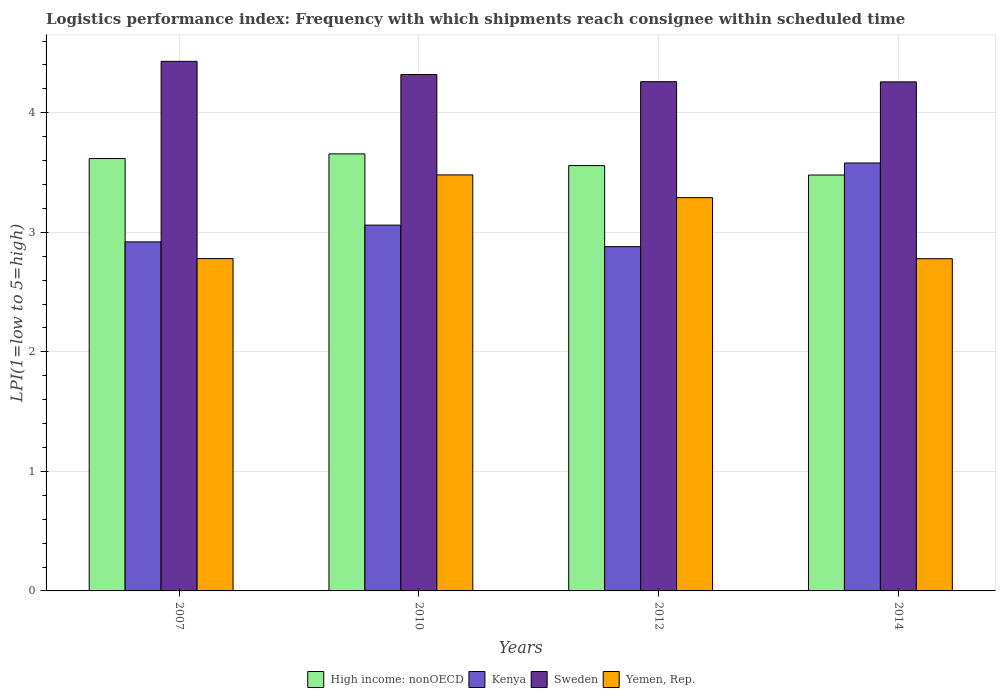How many different coloured bars are there?
Your answer should be very brief. 4. How many groups of bars are there?
Your response must be concise. 4. Are the number of bars on each tick of the X-axis equal?
Your answer should be compact. Yes. What is the label of the 1st group of bars from the left?
Ensure brevity in your answer.  2007. In how many cases, is the number of bars for a given year not equal to the number of legend labels?
Ensure brevity in your answer.  0. What is the logistics performance index in High income: nonOECD in 2014?
Give a very brief answer. 3.48. Across all years, what is the maximum logistics performance index in High income: nonOECD?
Your response must be concise. 3.66. Across all years, what is the minimum logistics performance index in High income: nonOECD?
Keep it short and to the point. 3.48. What is the total logistics performance index in Kenya in the graph?
Your answer should be compact. 12.44. What is the difference between the logistics performance index in Yemen, Rep. in 2007 and that in 2010?
Offer a terse response. -0.7. What is the difference between the logistics performance index in High income: nonOECD in 2007 and the logistics performance index in Yemen, Rep. in 2012?
Your answer should be compact. 0.33. What is the average logistics performance index in High income: nonOECD per year?
Your answer should be compact. 3.58. In the year 2012, what is the difference between the logistics performance index in High income: nonOECD and logistics performance index in Yemen, Rep.?
Keep it short and to the point. 0.27. What is the ratio of the logistics performance index in Yemen, Rep. in 2007 to that in 2012?
Your response must be concise. 0.84. Is the difference between the logistics performance index in High income: nonOECD in 2007 and 2010 greater than the difference between the logistics performance index in Yemen, Rep. in 2007 and 2010?
Your answer should be compact. Yes. What is the difference between the highest and the second highest logistics performance index in Kenya?
Offer a very short reply. 0.52. What is the difference between the highest and the lowest logistics performance index in Yemen, Rep.?
Your response must be concise. 0.7. Is the sum of the logistics performance index in Kenya in 2010 and 2014 greater than the maximum logistics performance index in High income: nonOECD across all years?
Your response must be concise. Yes. Is it the case that in every year, the sum of the logistics performance index in Sweden and logistics performance index in Kenya is greater than the sum of logistics performance index in High income: nonOECD and logistics performance index in Yemen, Rep.?
Give a very brief answer. Yes. What does the 4th bar from the left in 2014 represents?
Your answer should be compact. Yemen, Rep. What does the 4th bar from the right in 2012 represents?
Keep it short and to the point. High income: nonOECD. Are the values on the major ticks of Y-axis written in scientific E-notation?
Keep it short and to the point. No. Does the graph contain grids?
Make the answer very short. Yes. How many legend labels are there?
Offer a terse response. 4. How are the legend labels stacked?
Your response must be concise. Horizontal. What is the title of the graph?
Your answer should be very brief. Logistics performance index: Frequency with which shipments reach consignee within scheduled time. What is the label or title of the Y-axis?
Your response must be concise. LPI(1=low to 5=high). What is the LPI(1=low to 5=high) of High income: nonOECD in 2007?
Ensure brevity in your answer.  3.62. What is the LPI(1=low to 5=high) of Kenya in 2007?
Make the answer very short. 2.92. What is the LPI(1=low to 5=high) of Sweden in 2007?
Provide a short and direct response. 4.43. What is the LPI(1=low to 5=high) of Yemen, Rep. in 2007?
Your response must be concise. 2.78. What is the LPI(1=low to 5=high) of High income: nonOECD in 2010?
Offer a terse response. 3.66. What is the LPI(1=low to 5=high) in Kenya in 2010?
Offer a terse response. 3.06. What is the LPI(1=low to 5=high) of Sweden in 2010?
Your response must be concise. 4.32. What is the LPI(1=low to 5=high) of Yemen, Rep. in 2010?
Provide a succinct answer. 3.48. What is the LPI(1=low to 5=high) in High income: nonOECD in 2012?
Your answer should be compact. 3.56. What is the LPI(1=low to 5=high) of Kenya in 2012?
Your answer should be very brief. 2.88. What is the LPI(1=low to 5=high) of Sweden in 2012?
Offer a very short reply. 4.26. What is the LPI(1=low to 5=high) of Yemen, Rep. in 2012?
Your answer should be compact. 3.29. What is the LPI(1=low to 5=high) in High income: nonOECD in 2014?
Offer a very short reply. 3.48. What is the LPI(1=low to 5=high) in Kenya in 2014?
Your response must be concise. 3.58. What is the LPI(1=low to 5=high) in Sweden in 2014?
Your answer should be compact. 4.26. What is the LPI(1=low to 5=high) of Yemen, Rep. in 2014?
Ensure brevity in your answer.  2.78. Across all years, what is the maximum LPI(1=low to 5=high) in High income: nonOECD?
Make the answer very short. 3.66. Across all years, what is the maximum LPI(1=low to 5=high) of Kenya?
Provide a succinct answer. 3.58. Across all years, what is the maximum LPI(1=low to 5=high) of Sweden?
Make the answer very short. 4.43. Across all years, what is the maximum LPI(1=low to 5=high) in Yemen, Rep.?
Your answer should be compact. 3.48. Across all years, what is the minimum LPI(1=low to 5=high) in High income: nonOECD?
Offer a terse response. 3.48. Across all years, what is the minimum LPI(1=low to 5=high) of Kenya?
Ensure brevity in your answer.  2.88. Across all years, what is the minimum LPI(1=low to 5=high) of Sweden?
Give a very brief answer. 4.26. Across all years, what is the minimum LPI(1=low to 5=high) in Yemen, Rep.?
Offer a terse response. 2.78. What is the total LPI(1=low to 5=high) of High income: nonOECD in the graph?
Keep it short and to the point. 14.31. What is the total LPI(1=low to 5=high) in Kenya in the graph?
Your answer should be compact. 12.44. What is the total LPI(1=low to 5=high) of Sweden in the graph?
Your answer should be compact. 17.27. What is the total LPI(1=low to 5=high) of Yemen, Rep. in the graph?
Your answer should be very brief. 12.33. What is the difference between the LPI(1=low to 5=high) in High income: nonOECD in 2007 and that in 2010?
Provide a succinct answer. -0.04. What is the difference between the LPI(1=low to 5=high) in Kenya in 2007 and that in 2010?
Give a very brief answer. -0.14. What is the difference between the LPI(1=low to 5=high) in Sweden in 2007 and that in 2010?
Give a very brief answer. 0.11. What is the difference between the LPI(1=low to 5=high) in Yemen, Rep. in 2007 and that in 2010?
Ensure brevity in your answer.  -0.7. What is the difference between the LPI(1=low to 5=high) of High income: nonOECD in 2007 and that in 2012?
Provide a succinct answer. 0.06. What is the difference between the LPI(1=low to 5=high) in Sweden in 2007 and that in 2012?
Make the answer very short. 0.17. What is the difference between the LPI(1=low to 5=high) in Yemen, Rep. in 2007 and that in 2012?
Provide a short and direct response. -0.51. What is the difference between the LPI(1=low to 5=high) in High income: nonOECD in 2007 and that in 2014?
Your answer should be very brief. 0.14. What is the difference between the LPI(1=low to 5=high) of Kenya in 2007 and that in 2014?
Give a very brief answer. -0.66. What is the difference between the LPI(1=low to 5=high) of Sweden in 2007 and that in 2014?
Make the answer very short. 0.17. What is the difference between the LPI(1=low to 5=high) of Yemen, Rep. in 2007 and that in 2014?
Ensure brevity in your answer.  0. What is the difference between the LPI(1=low to 5=high) in High income: nonOECD in 2010 and that in 2012?
Provide a short and direct response. 0.1. What is the difference between the LPI(1=low to 5=high) of Kenya in 2010 and that in 2012?
Ensure brevity in your answer.  0.18. What is the difference between the LPI(1=low to 5=high) in Sweden in 2010 and that in 2012?
Your answer should be very brief. 0.06. What is the difference between the LPI(1=low to 5=high) of Yemen, Rep. in 2010 and that in 2012?
Make the answer very short. 0.19. What is the difference between the LPI(1=low to 5=high) in High income: nonOECD in 2010 and that in 2014?
Make the answer very short. 0.18. What is the difference between the LPI(1=low to 5=high) in Kenya in 2010 and that in 2014?
Your answer should be compact. -0.52. What is the difference between the LPI(1=low to 5=high) in Sweden in 2010 and that in 2014?
Make the answer very short. 0.06. What is the difference between the LPI(1=low to 5=high) of Yemen, Rep. in 2010 and that in 2014?
Keep it short and to the point. 0.7. What is the difference between the LPI(1=low to 5=high) of High income: nonOECD in 2012 and that in 2014?
Keep it short and to the point. 0.08. What is the difference between the LPI(1=low to 5=high) of Kenya in 2012 and that in 2014?
Provide a succinct answer. -0.7. What is the difference between the LPI(1=low to 5=high) of Sweden in 2012 and that in 2014?
Provide a succinct answer. 0. What is the difference between the LPI(1=low to 5=high) of Yemen, Rep. in 2012 and that in 2014?
Give a very brief answer. 0.51. What is the difference between the LPI(1=low to 5=high) in High income: nonOECD in 2007 and the LPI(1=low to 5=high) in Kenya in 2010?
Provide a short and direct response. 0.56. What is the difference between the LPI(1=low to 5=high) of High income: nonOECD in 2007 and the LPI(1=low to 5=high) of Sweden in 2010?
Your answer should be compact. -0.7. What is the difference between the LPI(1=low to 5=high) of High income: nonOECD in 2007 and the LPI(1=low to 5=high) of Yemen, Rep. in 2010?
Provide a succinct answer. 0.14. What is the difference between the LPI(1=low to 5=high) in Kenya in 2007 and the LPI(1=low to 5=high) in Yemen, Rep. in 2010?
Make the answer very short. -0.56. What is the difference between the LPI(1=low to 5=high) in High income: nonOECD in 2007 and the LPI(1=low to 5=high) in Kenya in 2012?
Keep it short and to the point. 0.74. What is the difference between the LPI(1=low to 5=high) of High income: nonOECD in 2007 and the LPI(1=low to 5=high) of Sweden in 2012?
Your response must be concise. -0.64. What is the difference between the LPI(1=low to 5=high) in High income: nonOECD in 2007 and the LPI(1=low to 5=high) in Yemen, Rep. in 2012?
Keep it short and to the point. 0.33. What is the difference between the LPI(1=low to 5=high) in Kenya in 2007 and the LPI(1=low to 5=high) in Sweden in 2012?
Keep it short and to the point. -1.34. What is the difference between the LPI(1=low to 5=high) in Kenya in 2007 and the LPI(1=low to 5=high) in Yemen, Rep. in 2012?
Ensure brevity in your answer.  -0.37. What is the difference between the LPI(1=low to 5=high) in Sweden in 2007 and the LPI(1=low to 5=high) in Yemen, Rep. in 2012?
Give a very brief answer. 1.14. What is the difference between the LPI(1=low to 5=high) in High income: nonOECD in 2007 and the LPI(1=low to 5=high) in Kenya in 2014?
Give a very brief answer. 0.04. What is the difference between the LPI(1=low to 5=high) in High income: nonOECD in 2007 and the LPI(1=low to 5=high) in Sweden in 2014?
Provide a succinct answer. -0.64. What is the difference between the LPI(1=low to 5=high) in High income: nonOECD in 2007 and the LPI(1=low to 5=high) in Yemen, Rep. in 2014?
Offer a very short reply. 0.84. What is the difference between the LPI(1=low to 5=high) of Kenya in 2007 and the LPI(1=low to 5=high) of Sweden in 2014?
Your answer should be very brief. -1.34. What is the difference between the LPI(1=low to 5=high) in Kenya in 2007 and the LPI(1=low to 5=high) in Yemen, Rep. in 2014?
Ensure brevity in your answer.  0.14. What is the difference between the LPI(1=low to 5=high) in Sweden in 2007 and the LPI(1=low to 5=high) in Yemen, Rep. in 2014?
Your response must be concise. 1.65. What is the difference between the LPI(1=low to 5=high) of High income: nonOECD in 2010 and the LPI(1=low to 5=high) of Kenya in 2012?
Give a very brief answer. 0.78. What is the difference between the LPI(1=low to 5=high) in High income: nonOECD in 2010 and the LPI(1=low to 5=high) in Sweden in 2012?
Provide a short and direct response. -0.6. What is the difference between the LPI(1=low to 5=high) of High income: nonOECD in 2010 and the LPI(1=low to 5=high) of Yemen, Rep. in 2012?
Provide a succinct answer. 0.37. What is the difference between the LPI(1=low to 5=high) of Kenya in 2010 and the LPI(1=low to 5=high) of Yemen, Rep. in 2012?
Give a very brief answer. -0.23. What is the difference between the LPI(1=low to 5=high) in High income: nonOECD in 2010 and the LPI(1=low to 5=high) in Kenya in 2014?
Make the answer very short. 0.08. What is the difference between the LPI(1=low to 5=high) in High income: nonOECD in 2010 and the LPI(1=low to 5=high) in Sweden in 2014?
Offer a terse response. -0.6. What is the difference between the LPI(1=low to 5=high) in High income: nonOECD in 2010 and the LPI(1=low to 5=high) in Yemen, Rep. in 2014?
Keep it short and to the point. 0.88. What is the difference between the LPI(1=low to 5=high) of Kenya in 2010 and the LPI(1=low to 5=high) of Sweden in 2014?
Give a very brief answer. -1.2. What is the difference between the LPI(1=low to 5=high) of Kenya in 2010 and the LPI(1=low to 5=high) of Yemen, Rep. in 2014?
Provide a succinct answer. 0.28. What is the difference between the LPI(1=low to 5=high) in Sweden in 2010 and the LPI(1=low to 5=high) in Yemen, Rep. in 2014?
Offer a terse response. 1.54. What is the difference between the LPI(1=low to 5=high) in High income: nonOECD in 2012 and the LPI(1=low to 5=high) in Kenya in 2014?
Keep it short and to the point. -0.02. What is the difference between the LPI(1=low to 5=high) of High income: nonOECD in 2012 and the LPI(1=low to 5=high) of Sweden in 2014?
Provide a short and direct response. -0.7. What is the difference between the LPI(1=low to 5=high) of High income: nonOECD in 2012 and the LPI(1=low to 5=high) of Yemen, Rep. in 2014?
Provide a short and direct response. 0.78. What is the difference between the LPI(1=low to 5=high) of Kenya in 2012 and the LPI(1=low to 5=high) of Sweden in 2014?
Your answer should be very brief. -1.38. What is the difference between the LPI(1=low to 5=high) of Kenya in 2012 and the LPI(1=low to 5=high) of Yemen, Rep. in 2014?
Keep it short and to the point. 0.1. What is the difference between the LPI(1=low to 5=high) of Sweden in 2012 and the LPI(1=low to 5=high) of Yemen, Rep. in 2014?
Offer a very short reply. 1.48. What is the average LPI(1=low to 5=high) of High income: nonOECD per year?
Provide a succinct answer. 3.58. What is the average LPI(1=low to 5=high) in Kenya per year?
Your response must be concise. 3.11. What is the average LPI(1=low to 5=high) in Sweden per year?
Your answer should be compact. 4.32. What is the average LPI(1=low to 5=high) in Yemen, Rep. per year?
Offer a very short reply. 3.08. In the year 2007, what is the difference between the LPI(1=low to 5=high) of High income: nonOECD and LPI(1=low to 5=high) of Kenya?
Give a very brief answer. 0.7. In the year 2007, what is the difference between the LPI(1=low to 5=high) of High income: nonOECD and LPI(1=low to 5=high) of Sweden?
Provide a short and direct response. -0.81. In the year 2007, what is the difference between the LPI(1=low to 5=high) of High income: nonOECD and LPI(1=low to 5=high) of Yemen, Rep.?
Provide a succinct answer. 0.84. In the year 2007, what is the difference between the LPI(1=low to 5=high) in Kenya and LPI(1=low to 5=high) in Sweden?
Provide a short and direct response. -1.51. In the year 2007, what is the difference between the LPI(1=low to 5=high) in Kenya and LPI(1=low to 5=high) in Yemen, Rep.?
Your answer should be very brief. 0.14. In the year 2007, what is the difference between the LPI(1=low to 5=high) in Sweden and LPI(1=low to 5=high) in Yemen, Rep.?
Your answer should be compact. 1.65. In the year 2010, what is the difference between the LPI(1=low to 5=high) of High income: nonOECD and LPI(1=low to 5=high) of Kenya?
Ensure brevity in your answer.  0.6. In the year 2010, what is the difference between the LPI(1=low to 5=high) of High income: nonOECD and LPI(1=low to 5=high) of Sweden?
Ensure brevity in your answer.  -0.66. In the year 2010, what is the difference between the LPI(1=low to 5=high) of High income: nonOECD and LPI(1=low to 5=high) of Yemen, Rep.?
Ensure brevity in your answer.  0.18. In the year 2010, what is the difference between the LPI(1=low to 5=high) in Kenya and LPI(1=low to 5=high) in Sweden?
Ensure brevity in your answer.  -1.26. In the year 2010, what is the difference between the LPI(1=low to 5=high) in Kenya and LPI(1=low to 5=high) in Yemen, Rep.?
Provide a short and direct response. -0.42. In the year 2010, what is the difference between the LPI(1=low to 5=high) in Sweden and LPI(1=low to 5=high) in Yemen, Rep.?
Offer a very short reply. 0.84. In the year 2012, what is the difference between the LPI(1=low to 5=high) in High income: nonOECD and LPI(1=low to 5=high) in Kenya?
Your response must be concise. 0.68. In the year 2012, what is the difference between the LPI(1=low to 5=high) of High income: nonOECD and LPI(1=low to 5=high) of Sweden?
Provide a succinct answer. -0.7. In the year 2012, what is the difference between the LPI(1=low to 5=high) in High income: nonOECD and LPI(1=low to 5=high) in Yemen, Rep.?
Ensure brevity in your answer.  0.27. In the year 2012, what is the difference between the LPI(1=low to 5=high) in Kenya and LPI(1=low to 5=high) in Sweden?
Provide a succinct answer. -1.38. In the year 2012, what is the difference between the LPI(1=low to 5=high) of Kenya and LPI(1=low to 5=high) of Yemen, Rep.?
Give a very brief answer. -0.41. In the year 2014, what is the difference between the LPI(1=low to 5=high) of High income: nonOECD and LPI(1=low to 5=high) of Kenya?
Make the answer very short. -0.1. In the year 2014, what is the difference between the LPI(1=low to 5=high) of High income: nonOECD and LPI(1=low to 5=high) of Sweden?
Ensure brevity in your answer.  -0.78. In the year 2014, what is the difference between the LPI(1=low to 5=high) in High income: nonOECD and LPI(1=low to 5=high) in Yemen, Rep.?
Offer a terse response. 0.7. In the year 2014, what is the difference between the LPI(1=low to 5=high) in Kenya and LPI(1=low to 5=high) in Sweden?
Offer a very short reply. -0.68. In the year 2014, what is the difference between the LPI(1=low to 5=high) of Kenya and LPI(1=low to 5=high) of Yemen, Rep.?
Provide a succinct answer. 0.8. In the year 2014, what is the difference between the LPI(1=low to 5=high) of Sweden and LPI(1=low to 5=high) of Yemen, Rep.?
Provide a short and direct response. 1.48. What is the ratio of the LPI(1=low to 5=high) in Kenya in 2007 to that in 2010?
Your response must be concise. 0.95. What is the ratio of the LPI(1=low to 5=high) in Sweden in 2007 to that in 2010?
Offer a terse response. 1.03. What is the ratio of the LPI(1=low to 5=high) of Yemen, Rep. in 2007 to that in 2010?
Provide a succinct answer. 0.8. What is the ratio of the LPI(1=low to 5=high) in High income: nonOECD in 2007 to that in 2012?
Ensure brevity in your answer.  1.02. What is the ratio of the LPI(1=low to 5=high) of Kenya in 2007 to that in 2012?
Give a very brief answer. 1.01. What is the ratio of the LPI(1=low to 5=high) of Sweden in 2007 to that in 2012?
Make the answer very short. 1.04. What is the ratio of the LPI(1=low to 5=high) of Yemen, Rep. in 2007 to that in 2012?
Provide a succinct answer. 0.84. What is the ratio of the LPI(1=low to 5=high) of High income: nonOECD in 2007 to that in 2014?
Your answer should be compact. 1.04. What is the ratio of the LPI(1=low to 5=high) of Kenya in 2007 to that in 2014?
Your answer should be very brief. 0.82. What is the ratio of the LPI(1=low to 5=high) in Sweden in 2007 to that in 2014?
Keep it short and to the point. 1.04. What is the ratio of the LPI(1=low to 5=high) in Yemen, Rep. in 2007 to that in 2014?
Give a very brief answer. 1. What is the ratio of the LPI(1=low to 5=high) of High income: nonOECD in 2010 to that in 2012?
Your answer should be compact. 1.03. What is the ratio of the LPI(1=low to 5=high) in Kenya in 2010 to that in 2012?
Keep it short and to the point. 1.06. What is the ratio of the LPI(1=low to 5=high) in Sweden in 2010 to that in 2012?
Ensure brevity in your answer.  1.01. What is the ratio of the LPI(1=low to 5=high) in Yemen, Rep. in 2010 to that in 2012?
Offer a very short reply. 1.06. What is the ratio of the LPI(1=low to 5=high) in High income: nonOECD in 2010 to that in 2014?
Offer a terse response. 1.05. What is the ratio of the LPI(1=low to 5=high) in Kenya in 2010 to that in 2014?
Ensure brevity in your answer.  0.85. What is the ratio of the LPI(1=low to 5=high) in Sweden in 2010 to that in 2014?
Give a very brief answer. 1.01. What is the ratio of the LPI(1=low to 5=high) in Yemen, Rep. in 2010 to that in 2014?
Your response must be concise. 1.25. What is the ratio of the LPI(1=low to 5=high) of High income: nonOECD in 2012 to that in 2014?
Provide a succinct answer. 1.02. What is the ratio of the LPI(1=low to 5=high) in Kenya in 2012 to that in 2014?
Your answer should be compact. 0.8. What is the ratio of the LPI(1=low to 5=high) of Yemen, Rep. in 2012 to that in 2014?
Ensure brevity in your answer.  1.18. What is the difference between the highest and the second highest LPI(1=low to 5=high) of High income: nonOECD?
Your response must be concise. 0.04. What is the difference between the highest and the second highest LPI(1=low to 5=high) of Kenya?
Provide a succinct answer. 0.52. What is the difference between the highest and the second highest LPI(1=low to 5=high) in Sweden?
Your response must be concise. 0.11. What is the difference between the highest and the second highest LPI(1=low to 5=high) of Yemen, Rep.?
Provide a short and direct response. 0.19. What is the difference between the highest and the lowest LPI(1=low to 5=high) of High income: nonOECD?
Provide a succinct answer. 0.18. What is the difference between the highest and the lowest LPI(1=low to 5=high) of Kenya?
Your answer should be very brief. 0.7. What is the difference between the highest and the lowest LPI(1=low to 5=high) of Sweden?
Offer a very short reply. 0.17. What is the difference between the highest and the lowest LPI(1=low to 5=high) in Yemen, Rep.?
Ensure brevity in your answer.  0.7. 